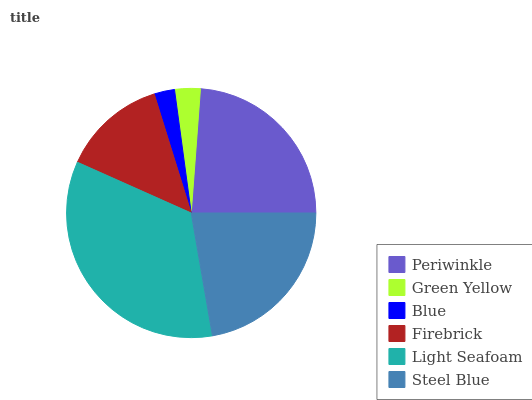Is Blue the minimum?
Answer yes or no. Yes. Is Light Seafoam the maximum?
Answer yes or no. Yes. Is Green Yellow the minimum?
Answer yes or no. No. Is Green Yellow the maximum?
Answer yes or no. No. Is Periwinkle greater than Green Yellow?
Answer yes or no. Yes. Is Green Yellow less than Periwinkle?
Answer yes or no. Yes. Is Green Yellow greater than Periwinkle?
Answer yes or no. No. Is Periwinkle less than Green Yellow?
Answer yes or no. No. Is Steel Blue the high median?
Answer yes or no. Yes. Is Firebrick the low median?
Answer yes or no. Yes. Is Blue the high median?
Answer yes or no. No. Is Steel Blue the low median?
Answer yes or no. No. 